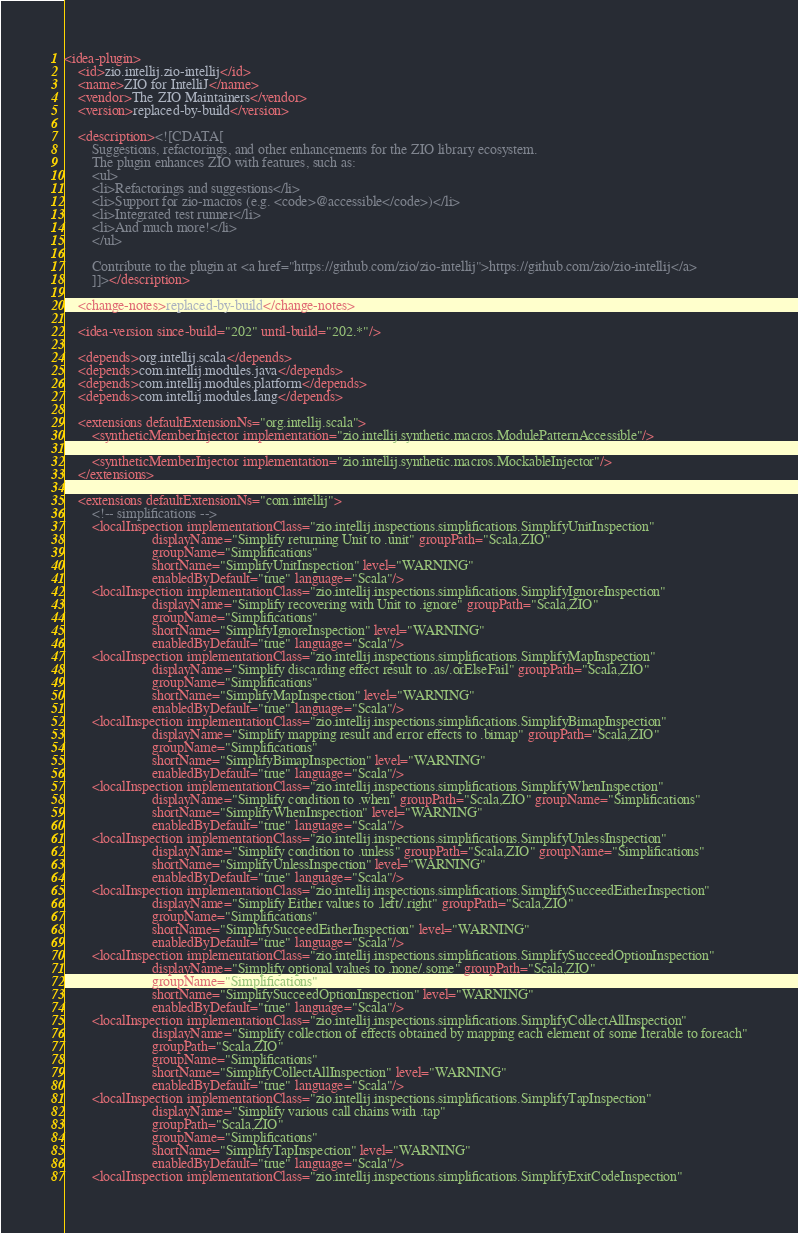<code> <loc_0><loc_0><loc_500><loc_500><_XML_><idea-plugin>
    <id>zio.intellij.zio-intellij</id>
    <name>ZIO for IntelliJ</name>
    <vendor>The ZIO Maintainers</vendor>
    <version>replaced-by-build</version>

    <description><![CDATA[
        Suggestions, refactorings, and other enhancements for the ZIO library ecosystem.
        The plugin enhances ZIO with features, such as:
        <ul>
        <li>Refactorings and suggestions</li>
        <li>Support for zio-macros (e.g. <code>@accessible</code>)</li>
        <li>Integrated test runner</li>
        <li>And much more!</li>
        </ul>

        Contribute to the plugin at <a href="https://github.com/zio/zio-intellij">https://github.com/zio/zio-intellij</a>
        ]]></description>

    <change-notes>replaced-by-build</change-notes>

    <idea-version since-build="202" until-build="202.*"/>

    <depends>org.intellij.scala</depends>
    <depends>com.intellij.modules.java</depends>
    <depends>com.intellij.modules.platform</depends>
    <depends>com.intellij.modules.lang</depends>

    <extensions defaultExtensionNs="org.intellij.scala">
        <syntheticMemberInjector implementation="zio.intellij.synthetic.macros.ModulePatternAccessible"/>

        <syntheticMemberInjector implementation="zio.intellij.synthetic.macros.MockableInjector"/>
    </extensions>

    <extensions defaultExtensionNs="com.intellij">
        <!-- simplifications -->
        <localInspection implementationClass="zio.intellij.inspections.simplifications.SimplifyUnitInspection"
                         displayName="Simplify returning Unit to .unit" groupPath="Scala,ZIO"
                         groupName="Simplifications"
                         shortName="SimplifyUnitInspection" level="WARNING"
                         enabledByDefault="true" language="Scala"/>
        <localInspection implementationClass="zio.intellij.inspections.simplifications.SimplifyIgnoreInspection"
                         displayName="Simplify recovering with Unit to .ignore" groupPath="Scala,ZIO"
                         groupName="Simplifications"
                         shortName="SimplifyIgnoreInspection" level="WARNING"
                         enabledByDefault="true" language="Scala"/>
        <localInspection implementationClass="zio.intellij.inspections.simplifications.SimplifyMapInspection"
                         displayName="Simplify discarding effect result to .as/.orElseFail" groupPath="Scala,ZIO"
                         groupName="Simplifications"
                         shortName="SimplifyMapInspection" level="WARNING"
                         enabledByDefault="true" language="Scala"/>
        <localInspection implementationClass="zio.intellij.inspections.simplifications.SimplifyBimapInspection"
                         displayName="Simplify mapping result and error effects to .bimap" groupPath="Scala,ZIO"
                         groupName="Simplifications"
                         shortName="SimplifyBimapInspection" level="WARNING"
                         enabledByDefault="true" language="Scala"/>
        <localInspection implementationClass="zio.intellij.inspections.simplifications.SimplifyWhenInspection"
                         displayName="Simplify condition to .when" groupPath="Scala,ZIO" groupName="Simplifications"
                         shortName="SimplifyWhenInspection" level="WARNING"
                         enabledByDefault="true" language="Scala"/>
        <localInspection implementationClass="zio.intellij.inspections.simplifications.SimplifyUnlessInspection"
                         displayName="Simplify condition to .unless" groupPath="Scala,ZIO" groupName="Simplifications"
                         shortName="SimplifyUnlessInspection" level="WARNING"
                         enabledByDefault="true" language="Scala"/>
        <localInspection implementationClass="zio.intellij.inspections.simplifications.SimplifySucceedEitherInspection"
                         displayName="Simplify Either values to .left/.right" groupPath="Scala,ZIO"
                         groupName="Simplifications"
                         shortName="SimplifySucceedEitherInspection" level="WARNING"
                         enabledByDefault="true" language="Scala"/>
        <localInspection implementationClass="zio.intellij.inspections.simplifications.SimplifySucceedOptionInspection"
                         displayName="Simplify optional values to .none/.some" groupPath="Scala,ZIO"
                         groupName="Simplifications"
                         shortName="SimplifySucceedOptionInspection" level="WARNING"
                         enabledByDefault="true" language="Scala"/>
        <localInspection implementationClass="zio.intellij.inspections.simplifications.SimplifyCollectAllInspection"
                         displayName="Simplify collection of effects obtained by mapping each element of some Iterable to foreach"
                         groupPath="Scala,ZIO"
                         groupName="Simplifications"
                         shortName="SimplifyCollectAllInspection" level="WARNING"
                         enabledByDefault="true" language="Scala"/>
        <localInspection implementationClass="zio.intellij.inspections.simplifications.SimplifyTapInspection"
                         displayName="Simplify various call chains with .tap"
                         groupPath="Scala,ZIO"
                         groupName="Simplifications"
                         shortName="SimplifyTapInspection" level="WARNING"
                         enabledByDefault="true" language="Scala"/>
        <localInspection implementationClass="zio.intellij.inspections.simplifications.SimplifyExitCodeInspection"</code> 